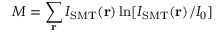Convert formula to latex. <formula><loc_0><loc_0><loc_500><loc_500>M = \sum _ { r } I _ { S M T } ( { r } ) \ln [ I _ { S M T } ( { r } ) / I _ { 0 } ]</formula> 